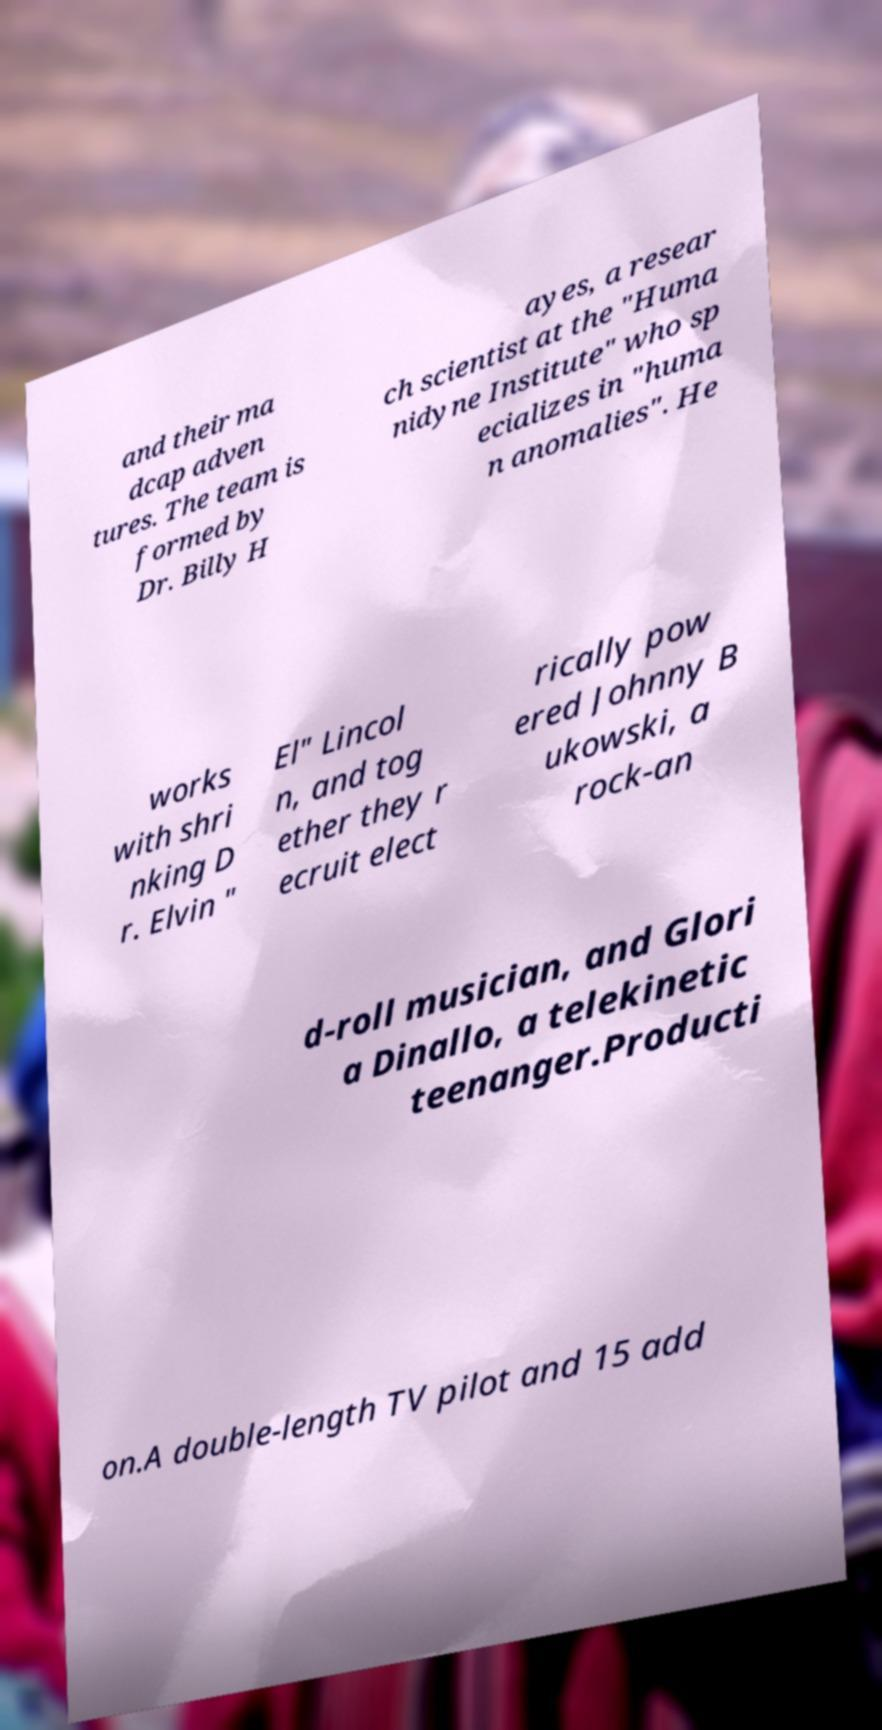Please identify and transcribe the text found in this image. and their ma dcap adven tures. The team is formed by Dr. Billy H ayes, a resear ch scientist at the "Huma nidyne Institute" who sp ecializes in "huma n anomalies". He works with shri nking D r. Elvin " El" Lincol n, and tog ether they r ecruit elect rically pow ered Johnny B ukowski, a rock-an d-roll musician, and Glori a Dinallo, a telekinetic teenanger.Producti on.A double-length TV pilot and 15 add 